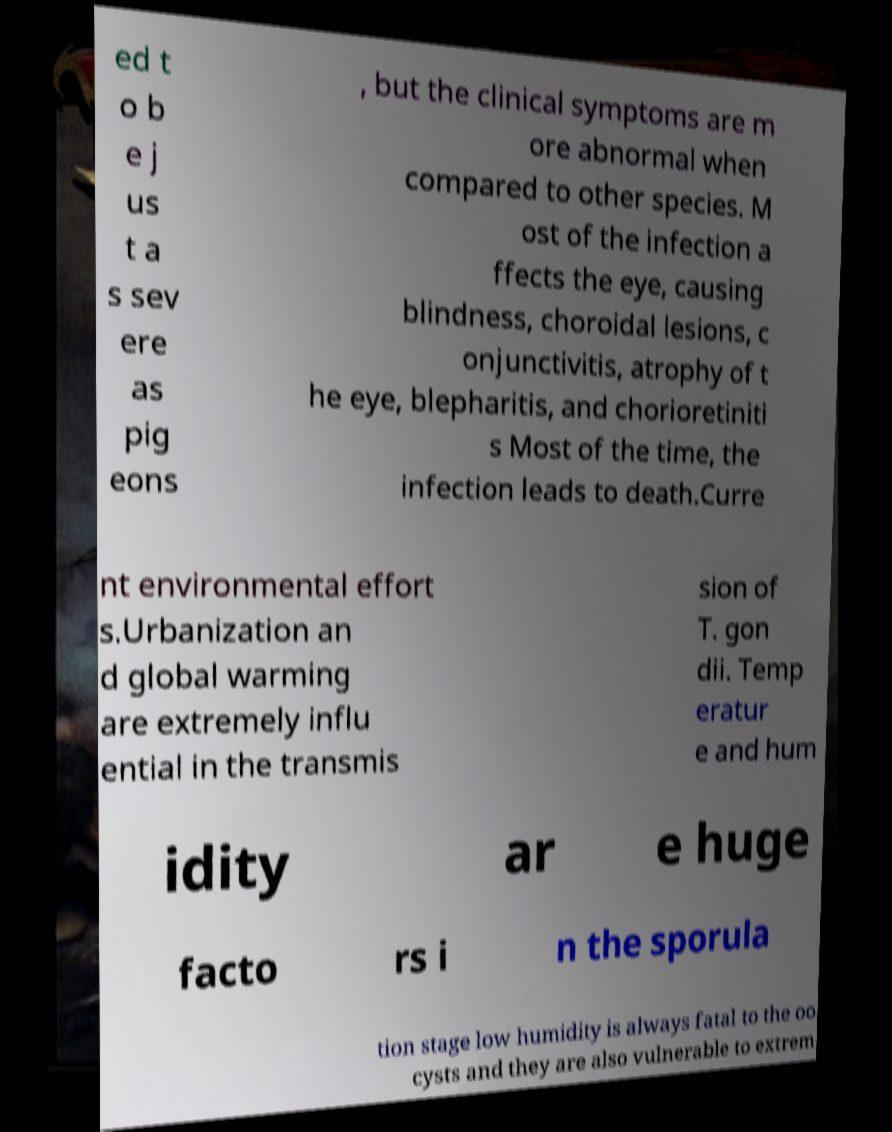Could you extract and type out the text from this image? ed t o b e j us t a s sev ere as pig eons , but the clinical symptoms are m ore abnormal when compared to other species. M ost of the infection a ffects the eye, causing blindness, choroidal lesions, c onjunctivitis, atrophy of t he eye, blepharitis, and chorioretiniti s Most of the time, the infection leads to death.Curre nt environmental effort s.Urbanization an d global warming are extremely influ ential in the transmis sion of T. gon dii. Temp eratur e and hum idity ar e huge facto rs i n the sporula tion stage low humidity is always fatal to the oo cysts and they are also vulnerable to extrem 